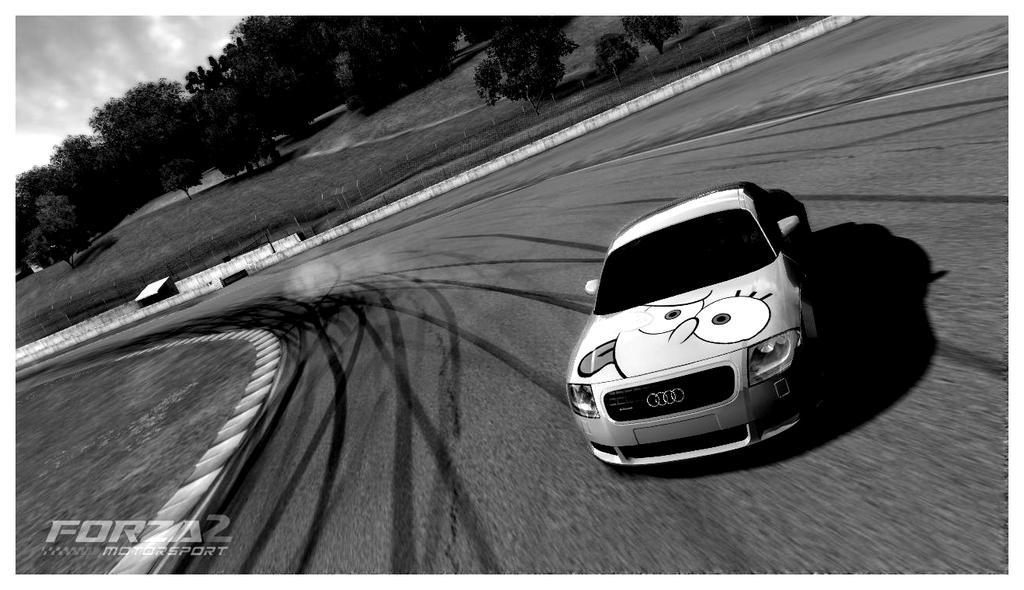Describe this image in one or two sentences. As we can see in the image there is a road, white color car, grass, trees, sky and clouds. The image is little dark. 